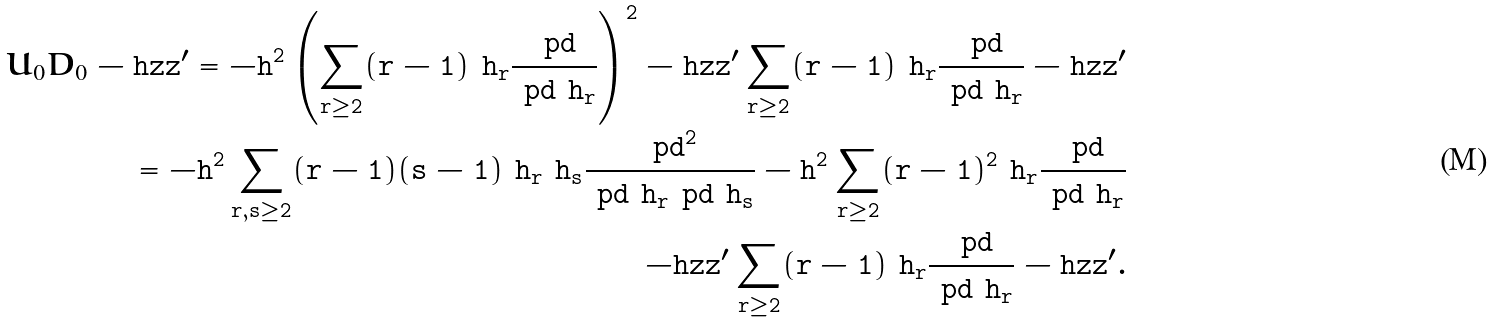<formula> <loc_0><loc_0><loc_500><loc_500>U _ { 0 } D _ { 0 } - \tt h z z ^ { \prime } = - \tt h ^ { 2 } \left ( \sum _ { r \geq 2 } ( r - 1 ) \ h _ { r } \frac { \ p d } { \ p d \ h _ { r } } \right ) ^ { 2 } - \tt h z z ^ { \prime } \sum _ { r \geq 2 } ( r - 1 ) \ h _ { r } \frac { \ p d } { \ p d \ h _ { r } } - \tt h z z ^ { \prime } \\ = - \tt h ^ { 2 } \sum _ { r , s \geq 2 } ( r - 1 ) ( s - 1 ) \ h _ { r } \ h _ { s } \frac { \ p d ^ { 2 } } { \ p d \ h _ { r } \ p d \ h _ { s } } - \tt h ^ { 2 } \sum _ { r \geq 2 } ( r - 1 ) ^ { 2 } \ h _ { r } \frac { \ p d } { \ p d \ h _ { r } } \\ - \tt h z z ^ { \prime } \sum _ { r \geq 2 } ( r - 1 ) \ h _ { r } \frac { \ p d } { \ p d \ h _ { r } } - \tt h z z ^ { \prime } .</formula> 